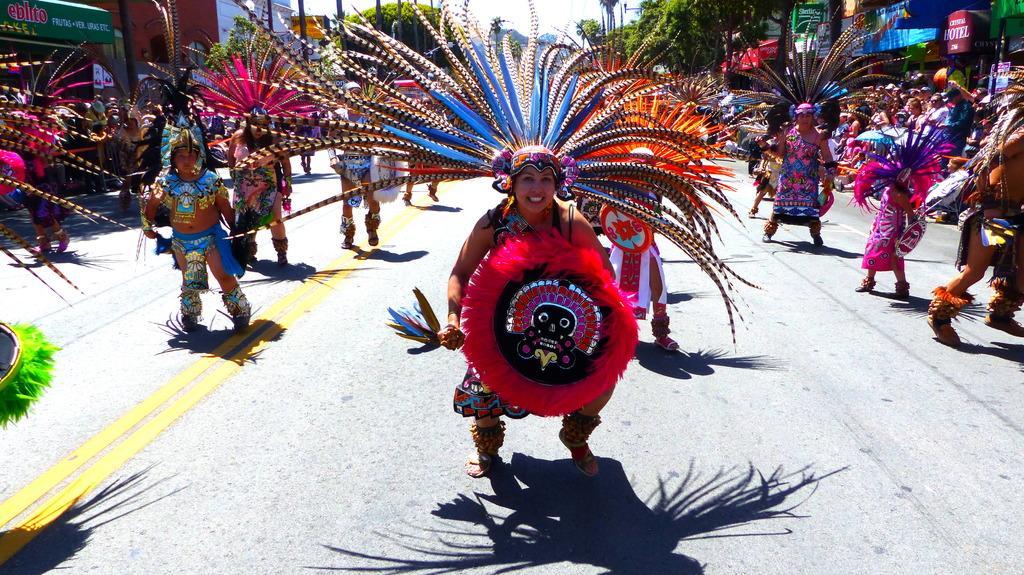Can you describe this image briefly? In the picture we can see some women are dancing on the road and they are in a colorful costumes and on the either sides of the road we can see some shops, buildings, trees, poles and a sky. 